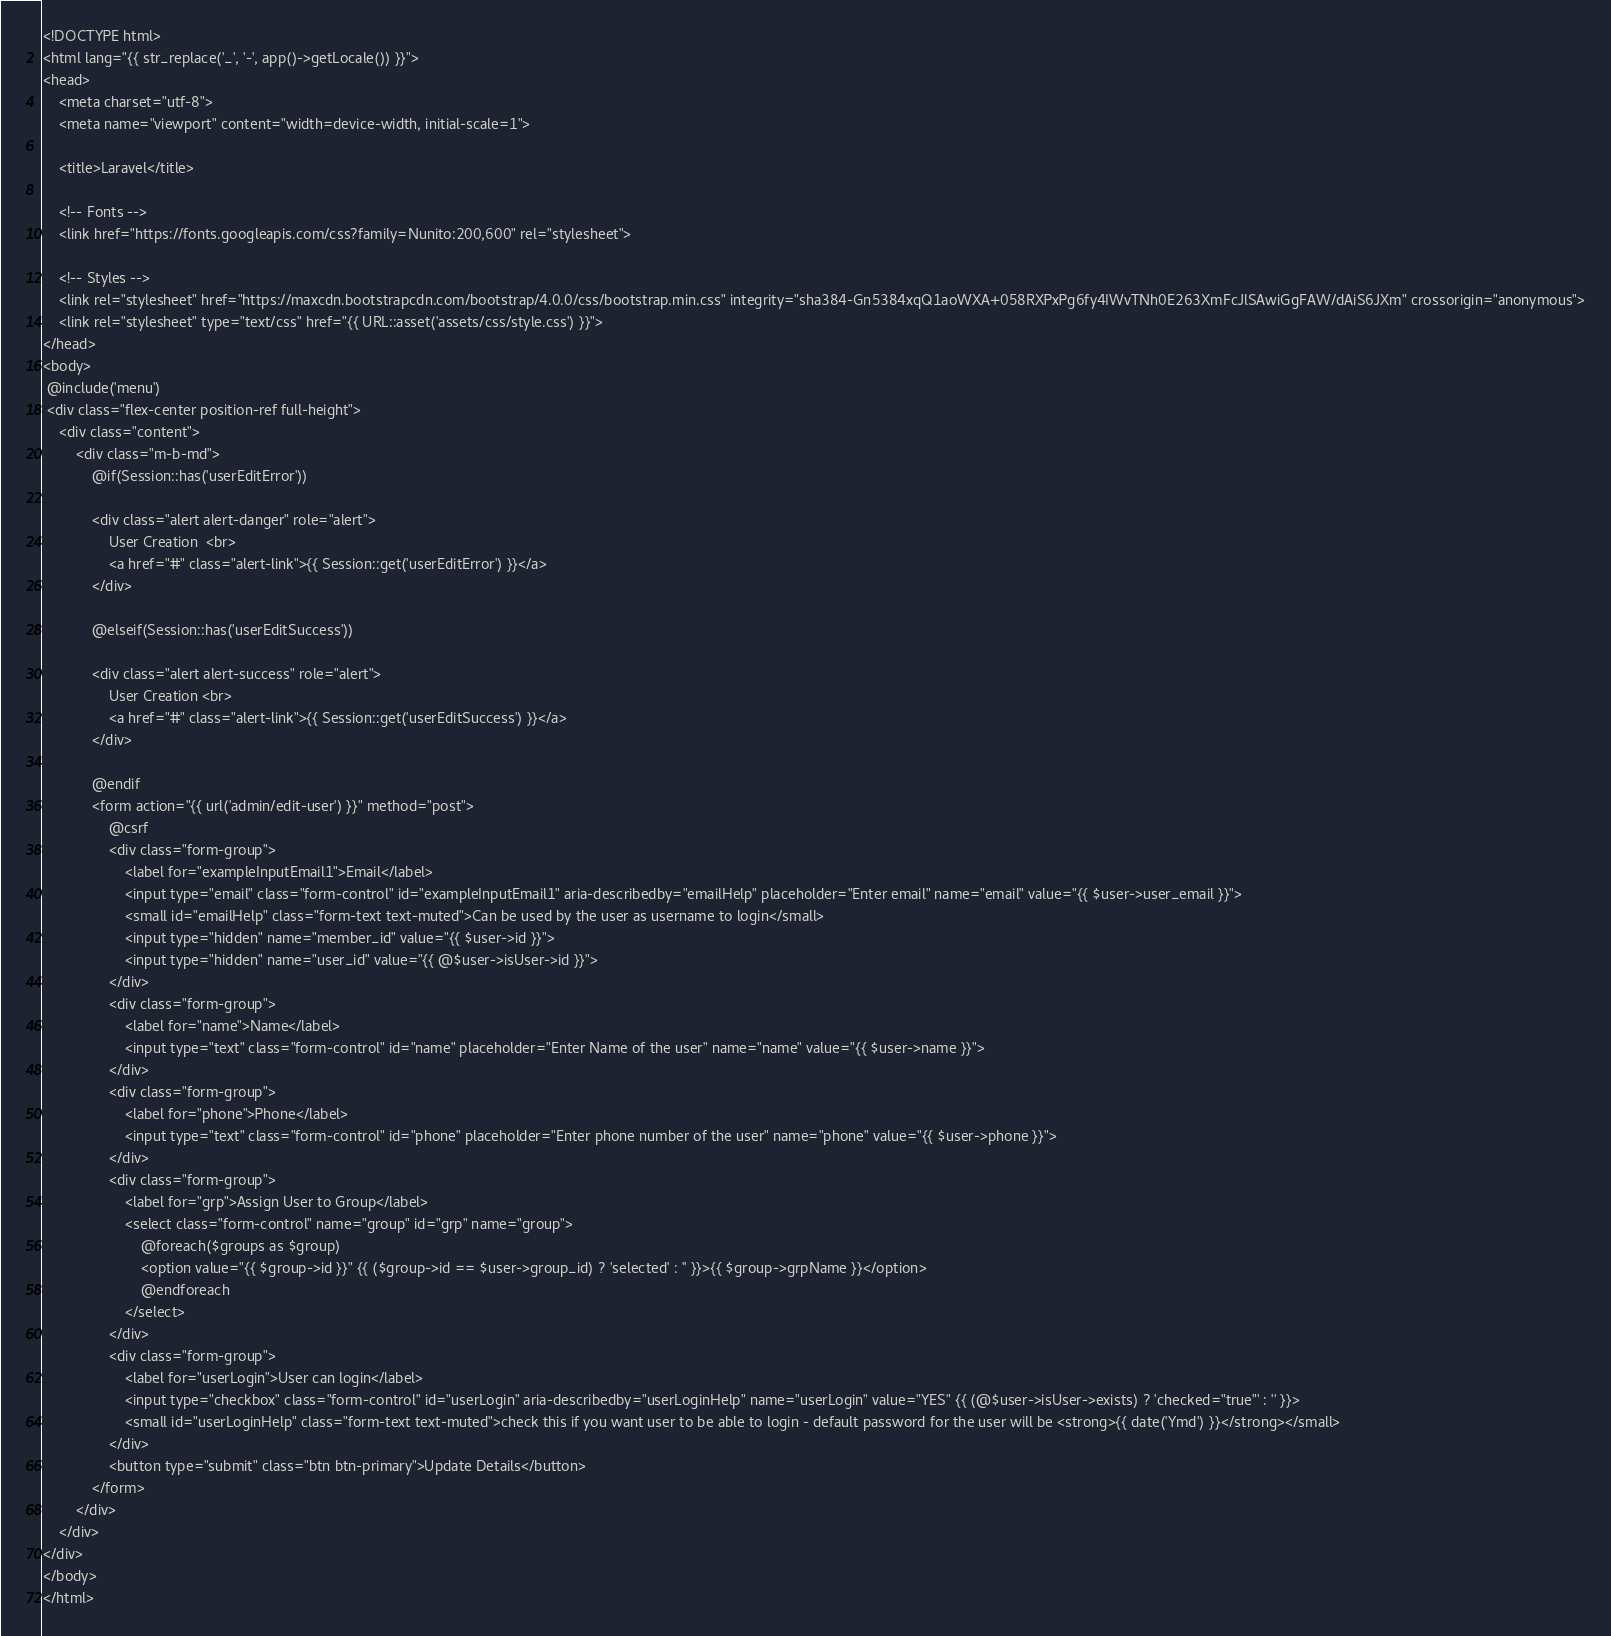Convert code to text. <code><loc_0><loc_0><loc_500><loc_500><_PHP_><!DOCTYPE html>
<html lang="{{ str_replace('_', '-', app()->getLocale()) }}">
<head>
    <meta charset="utf-8">
    <meta name="viewport" content="width=device-width, initial-scale=1">

    <title>Laravel</title>

    <!-- Fonts -->
    <link href="https://fonts.googleapis.com/css?family=Nunito:200,600" rel="stylesheet">

    <!-- Styles -->
    <link rel="stylesheet" href="https://maxcdn.bootstrapcdn.com/bootstrap/4.0.0/css/bootstrap.min.css" integrity="sha384-Gn5384xqQ1aoWXA+058RXPxPg6fy4IWvTNh0E263XmFcJlSAwiGgFAW/dAiS6JXm" crossorigin="anonymous">
    <link rel="stylesheet" type="text/css" href="{{ URL::asset('assets/css/style.css') }}">
</head>
<body>
 @include('menu')
 <div class="flex-center position-ref full-height">
    <div class="content">
        <div class="m-b-md">
            @if(Session::has('userEditError'))

            <div class="alert alert-danger" role="alert">
                User Creation  <br>
                <a href="#" class="alert-link">{{ Session::get('userEditError') }}</a>
            </div>

            @elseif(Session::has('userEditSuccess'))

            <div class="alert alert-success" role="alert">
                User Creation <br>
                <a href="#" class="alert-link">{{ Session::get('userEditSuccess') }}</a>
            </div>

            @endif
            <form action="{{ url('admin/edit-user') }}" method="post">
                @csrf
                <div class="form-group">
                    <label for="exampleInputEmail1">Email</label>
                    <input type="email" class="form-control" id="exampleInputEmail1" aria-describedby="emailHelp" placeholder="Enter email" name="email" value="{{ $user->user_email }}">
                    <small id="emailHelp" class="form-text text-muted">Can be used by the user as username to login</small>
                    <input type="hidden" name="member_id" value="{{ $user->id }}">
                    <input type="hidden" name="user_id" value="{{ @$user->isUser->id }}">
                </div>
                <div class="form-group">
                    <label for="name">Name</label>
                    <input type="text" class="form-control" id="name" placeholder="Enter Name of the user" name="name" value="{{ $user->name }}">
                </div>
                <div class="form-group">
                    <label for="phone">Phone</label>
                    <input type="text" class="form-control" id="phone" placeholder="Enter phone number of the user" name="phone" value="{{ $user->phone }}">
                </div>
                <div class="form-group">
                    <label for="grp">Assign User to Group</label>
                    <select class="form-control" name="group" id="grp" name="group">
                        @foreach($groups as $group)
                        <option value="{{ $group->id }}" {{ ($group->id == $user->group_id) ? 'selected' : '' }}>{{ $group->grpName }}</option>
                        @endforeach
                    </select>
                </div>
                <div class="form-group">
                    <label for="userLogin">User can login</label>
                    <input type="checkbox" class="form-control" id="userLogin" aria-describedby="userLoginHelp" name="userLogin" value="YES" {{ (@$user->isUser->exists) ? 'checked="true"' : '' }}>
                    <small id="userLoginHelp" class="form-text text-muted">check this if you want user to be able to login - default password for the user will be <strong>{{ date('Ymd') }}</strong></small>
                </div>
                <button type="submit" class="btn btn-primary">Update Details</button>
            </form>
        </div>
    </div>
</div>
</body>
</html>
</code> 